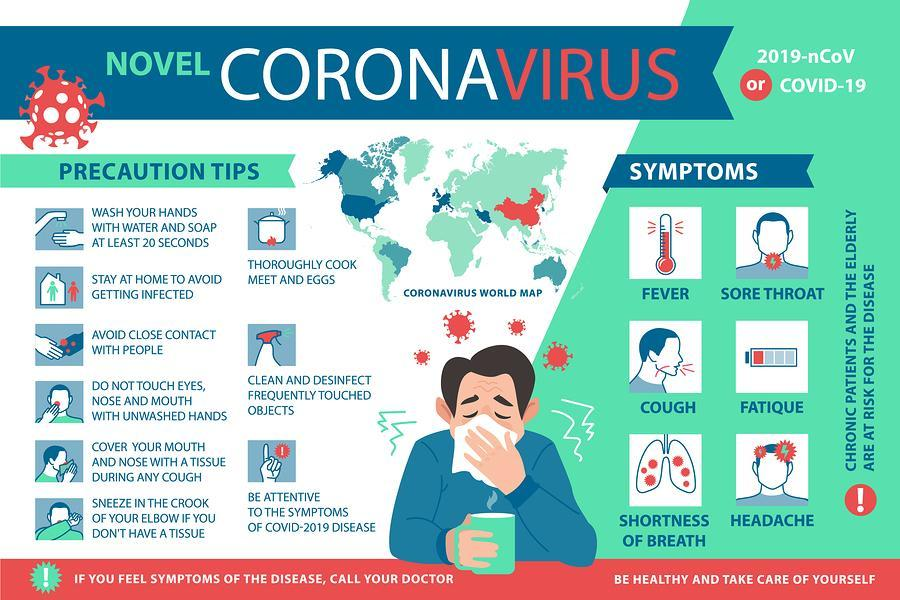How many symptoms are shown in the image?
Answer the question with a short phrase. 6 How many precaution tips are shown in the image? 9 What is the second symptom shown in the second row? fatigue What shouldn't be touched with unwashed hands? eyes, nose and mouth What are the first three symptoms shown in the image? fever, sore throat, cough What is the first symptom shown in the third row? shortness of breath What is the second symptom shown in the third row? headache 